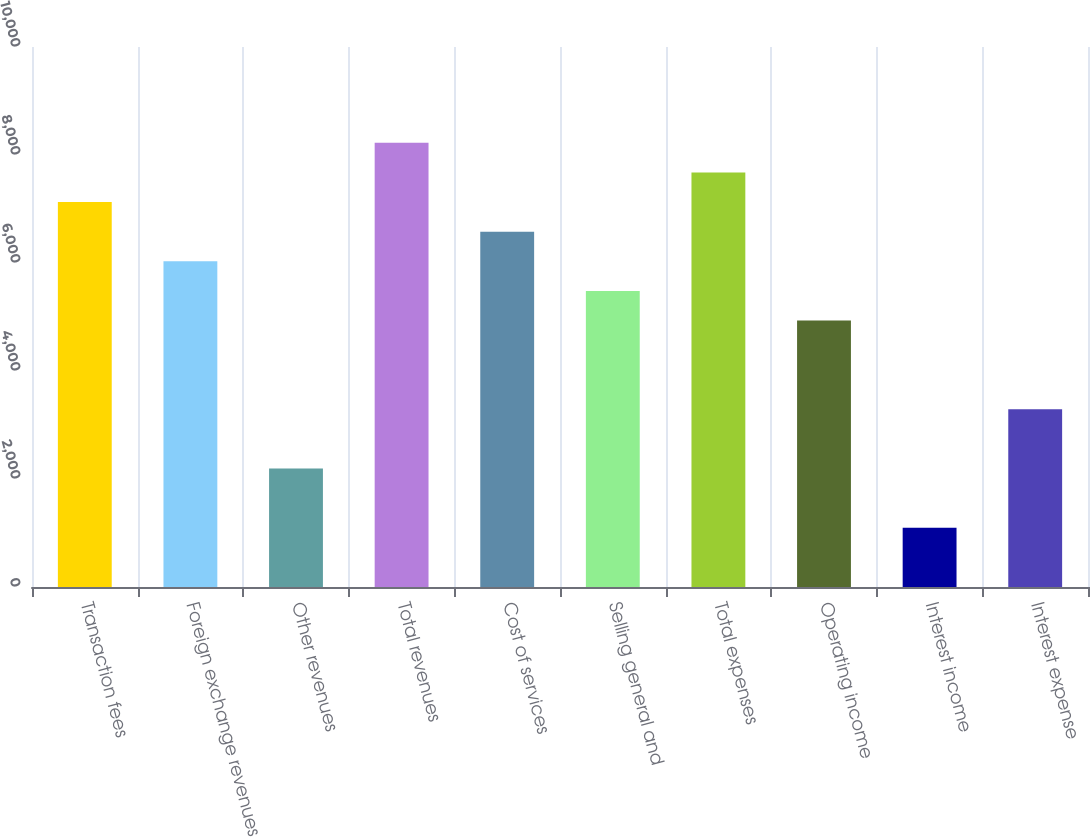Convert chart to OTSL. <chart><loc_0><loc_0><loc_500><loc_500><bar_chart><fcel>Transaction fees<fcel>Foreign exchange revenues<fcel>Other revenues<fcel>Total revenues<fcel>Cost of services<fcel>Selling general and<fcel>Total expenses<fcel>Operating income<fcel>Interest income<fcel>Interest expense<nl><fcel>7128.35<fcel>6031.93<fcel>2194.46<fcel>8224.77<fcel>6580.14<fcel>5483.72<fcel>7676.56<fcel>4935.51<fcel>1098.04<fcel>3290.88<nl></chart> 